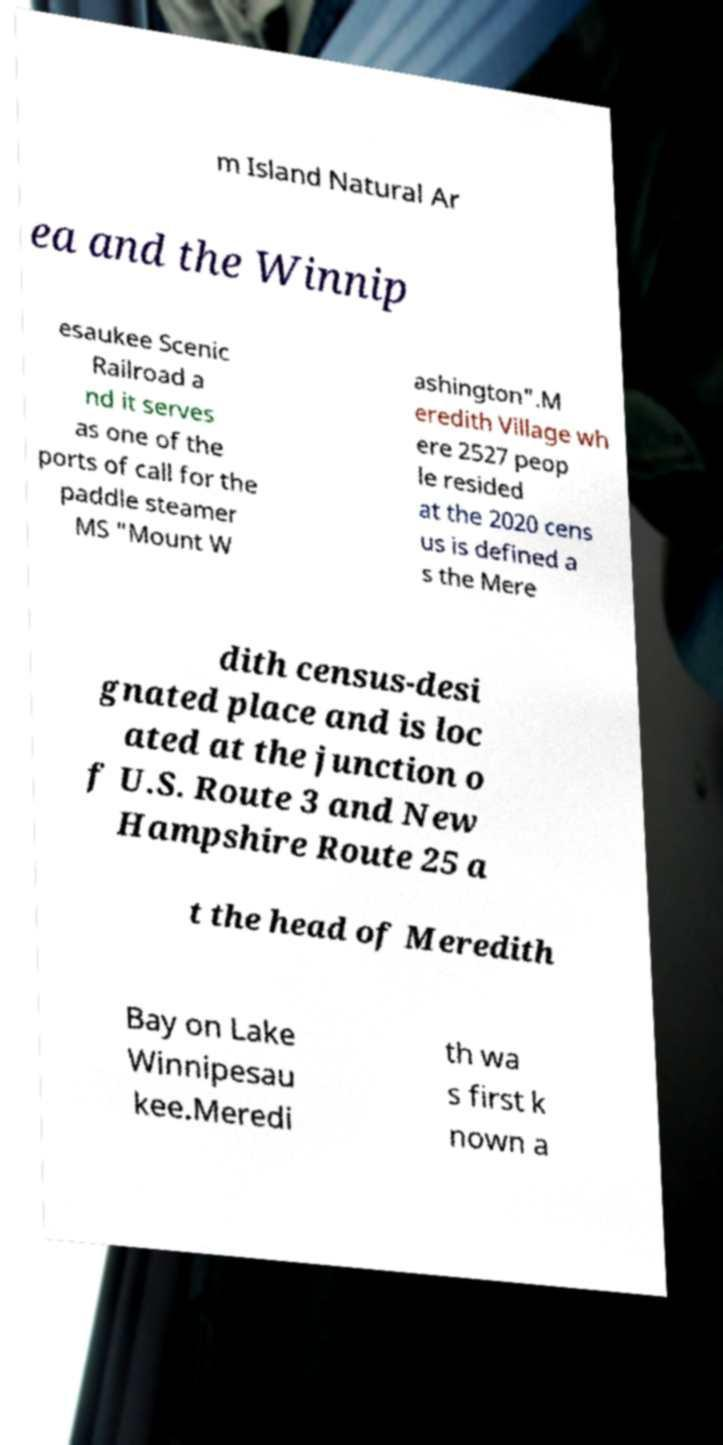What messages or text are displayed in this image? I need them in a readable, typed format. m Island Natural Ar ea and the Winnip esaukee Scenic Railroad a nd it serves as one of the ports of call for the paddle steamer MS "Mount W ashington".M eredith Village wh ere 2527 peop le resided at the 2020 cens us is defined a s the Mere dith census-desi gnated place and is loc ated at the junction o f U.S. Route 3 and New Hampshire Route 25 a t the head of Meredith Bay on Lake Winnipesau kee.Meredi th wa s first k nown a 